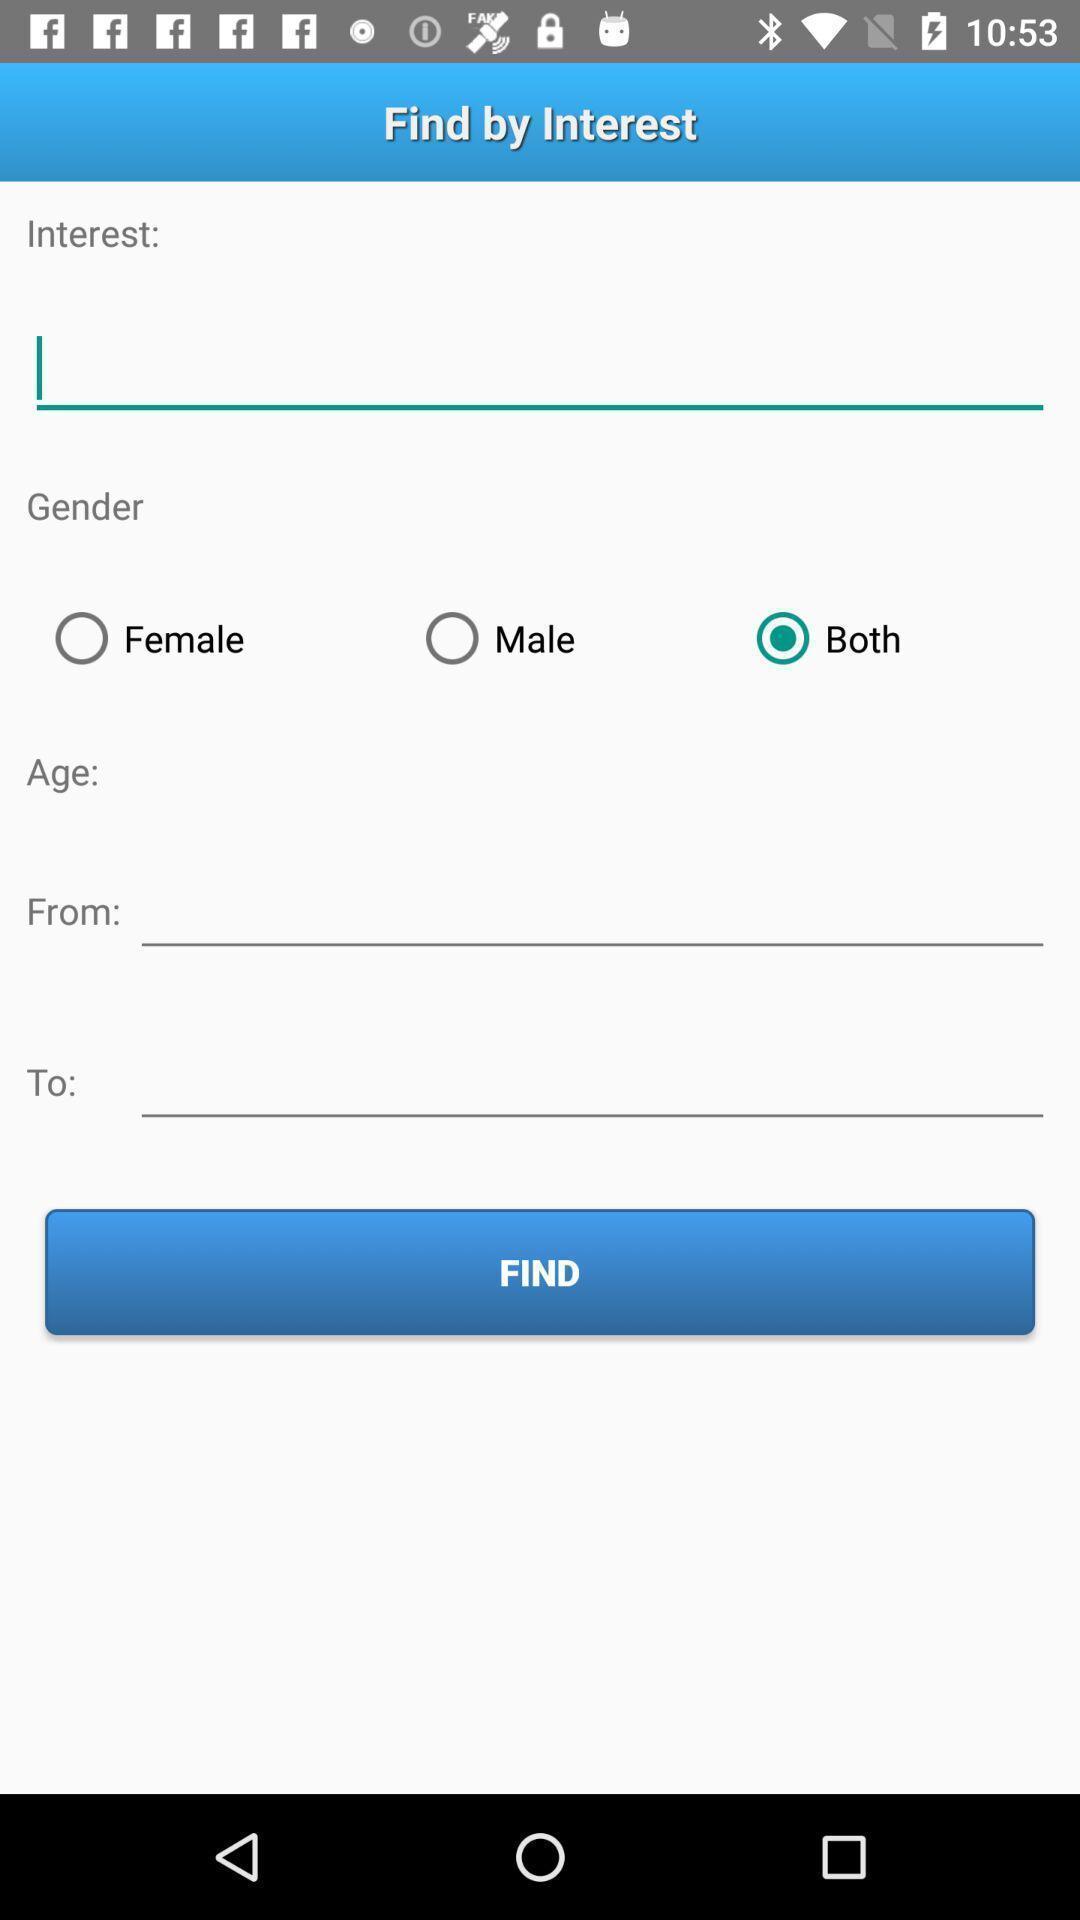What is the overall content of this screenshot? Page for finding by interest. 